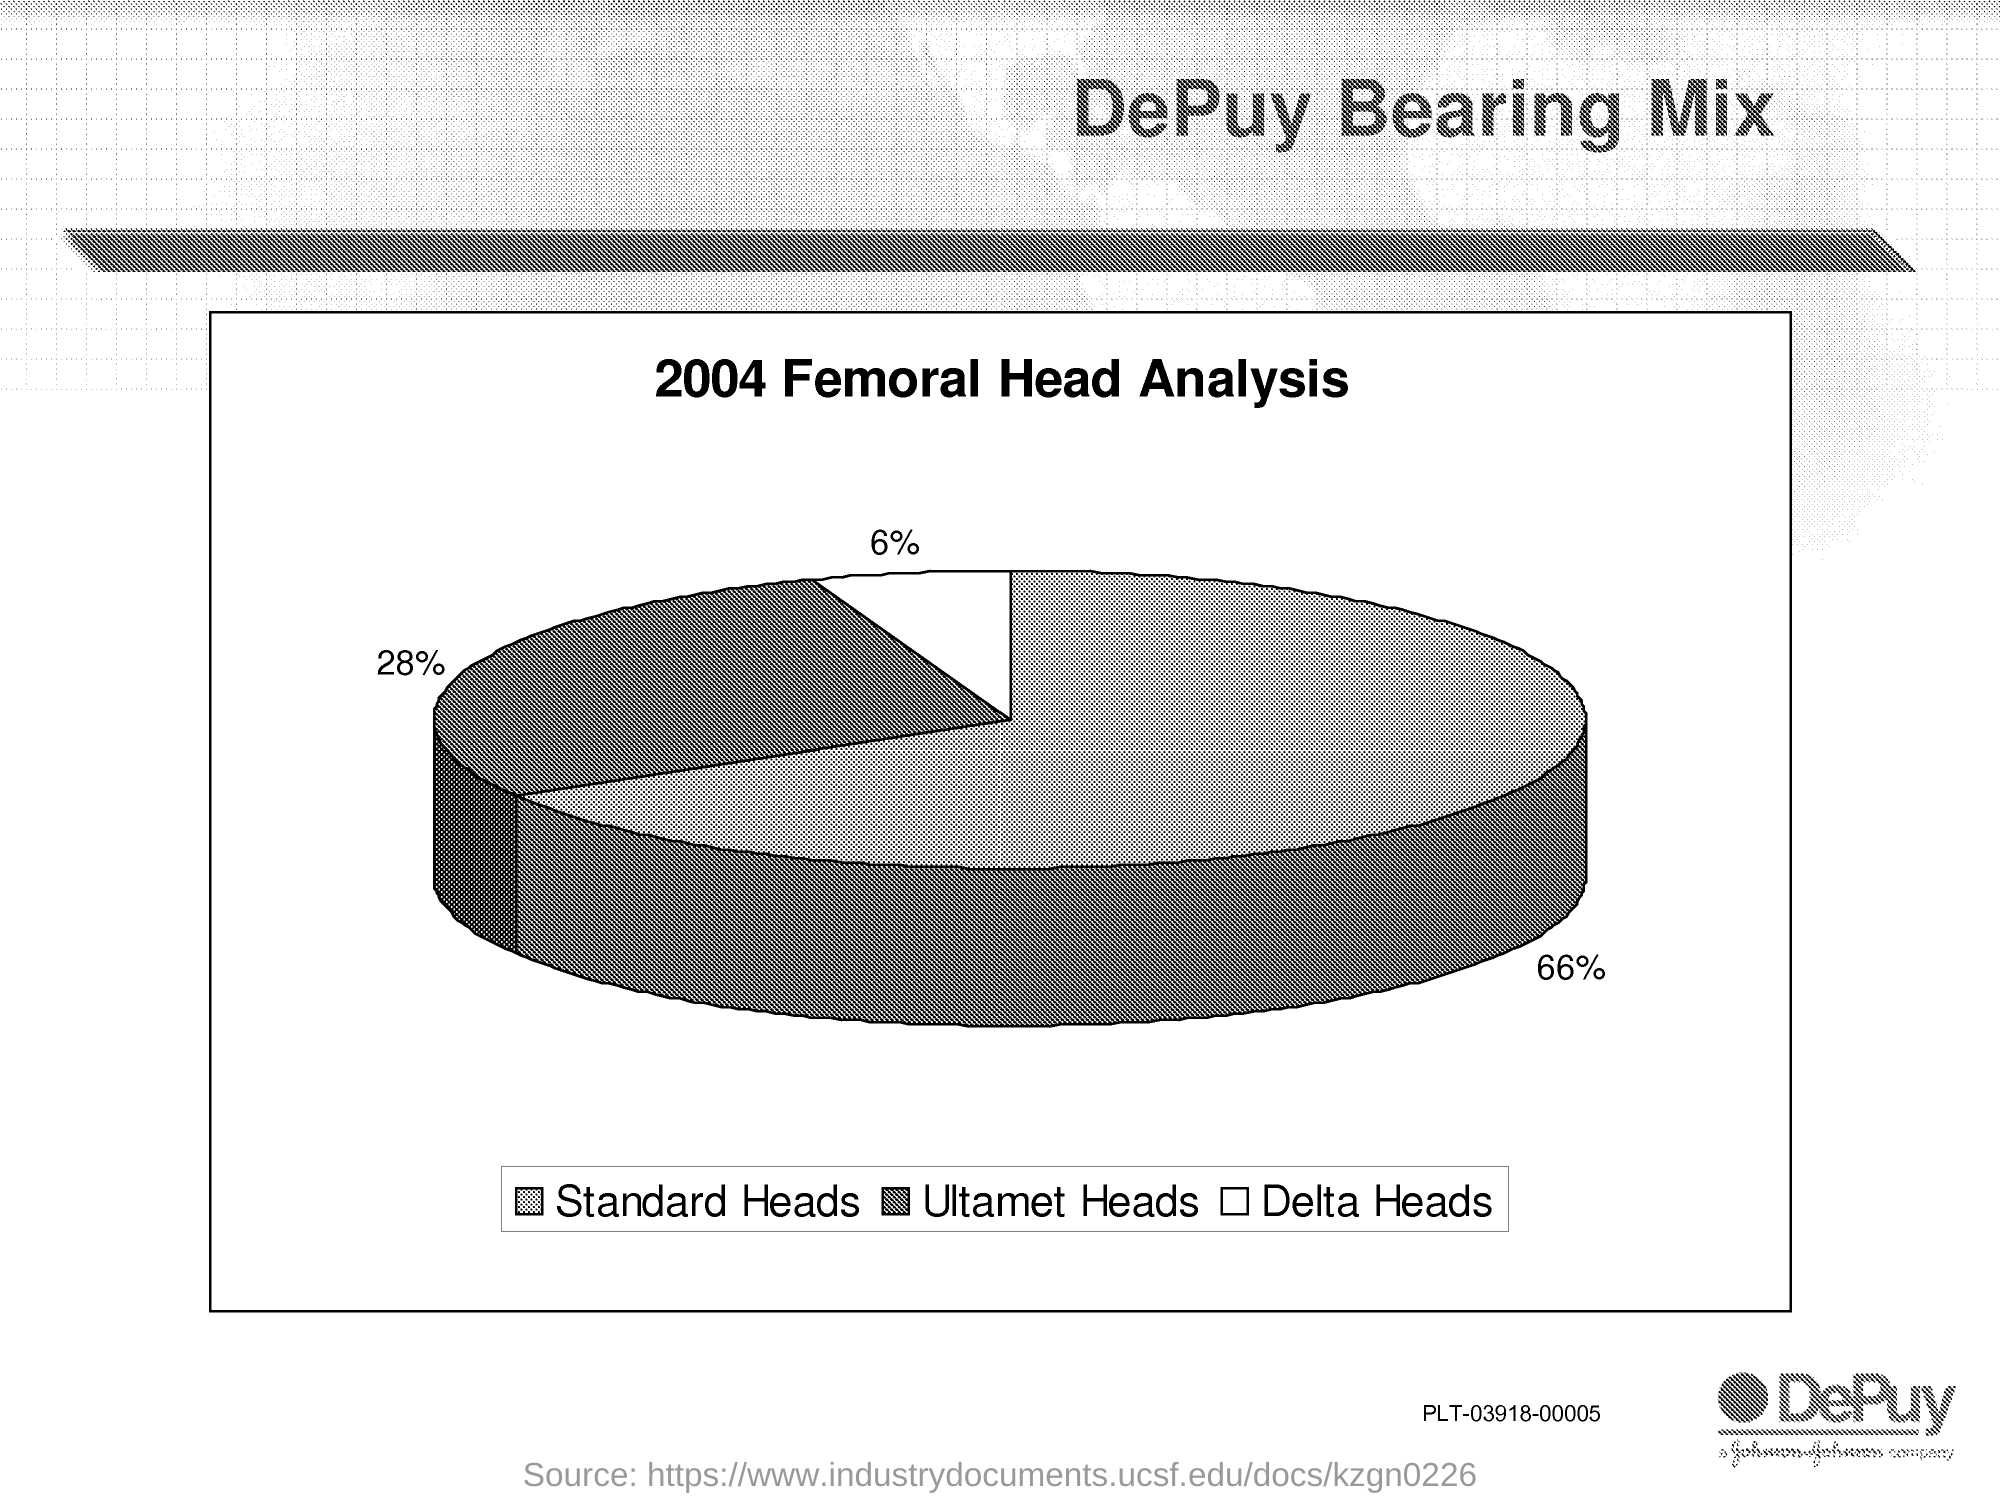What is the title of this piechart?
Keep it short and to the point. 2004 Femoral Head Analysis. What percentage of Standard heads are shown on the piechart?
Provide a succinct answer. 66%. What percentage of Ultamet heads are shown on the piechart?
Provide a succinct answer. 28%. What percentage of Delta heads are shown on the piechart?
Make the answer very short. 6%. 